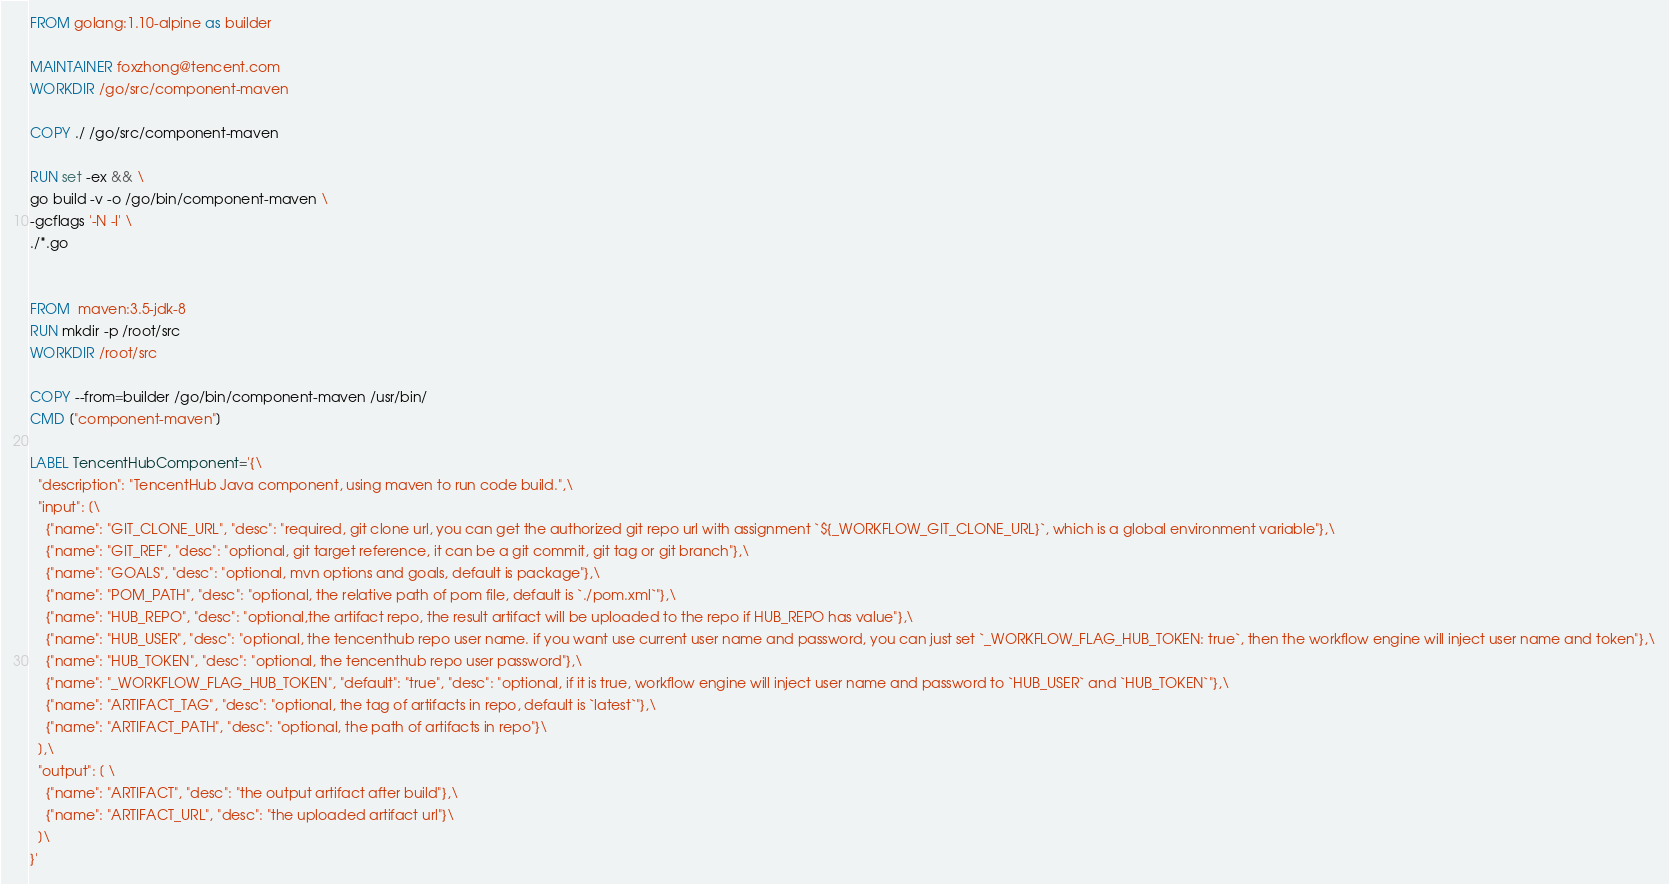Convert code to text. <code><loc_0><loc_0><loc_500><loc_500><_Dockerfile_>FROM golang:1.10-alpine as builder

MAINTAINER foxzhong@tencent.com
WORKDIR /go/src/component-maven

COPY ./ /go/src/component-maven

RUN set -ex && \
go build -v -o /go/bin/component-maven \
-gcflags '-N -l' \
./*.go


FROM  maven:3.5-jdk-8
RUN mkdir -p /root/src
WORKDIR /root/src

COPY --from=builder /go/bin/component-maven /usr/bin/
CMD ["component-maven"]

LABEL TencentHubComponent='{\
  "description": "TencentHub Java component, using maven to run code build.",\
  "input": [\
    {"name": "GIT_CLONE_URL", "desc": "required, git clone url, you can get the authorized git repo url with assignment `${_WORKFLOW_GIT_CLONE_URL}`, which is a global environment variable"},\
    {"name": "GIT_REF", "desc": "optional, git target reference, it can be a git commit, git tag or git branch"},\
    {"name": "GOALS", "desc": "optional, mvn options and goals, default is package"},\
    {"name": "POM_PATH", "desc": "optional, the relative path of pom file, default is `./pom.xml`"},\
    {"name": "HUB_REPO", "desc": "optional,the artifact repo, the result artifact will be uploaded to the repo if HUB_REPO has value"},\
    {"name": "HUB_USER", "desc": "optional, the tencenthub repo user name. if you want use current user name and password, you can just set `_WORKFLOW_FLAG_HUB_TOKEN: true`, then the workflow engine will inject user name and token"},\
    {"name": "HUB_TOKEN", "desc": "optional, the tencenthub repo user password"},\
    {"name": "_WORKFLOW_FLAG_HUB_TOKEN", "default": "true", "desc": "optional, if it is true, workflow engine will inject user name and password to `HUB_USER` and `HUB_TOKEN`"},\
    {"name": "ARTIFACT_TAG", "desc": "optional, the tag of artifacts in repo, default is `latest`"},\
    {"name": "ARTIFACT_PATH", "desc": "optional, the path of artifacts in repo"}\
  ],\
  "output": [ \
    {"name": "ARTIFACT", "desc": "the output artifact after build"},\
    {"name": "ARTIFACT_URL", "desc": "the uploaded artifact url"}\
  ]\
}'
</code> 